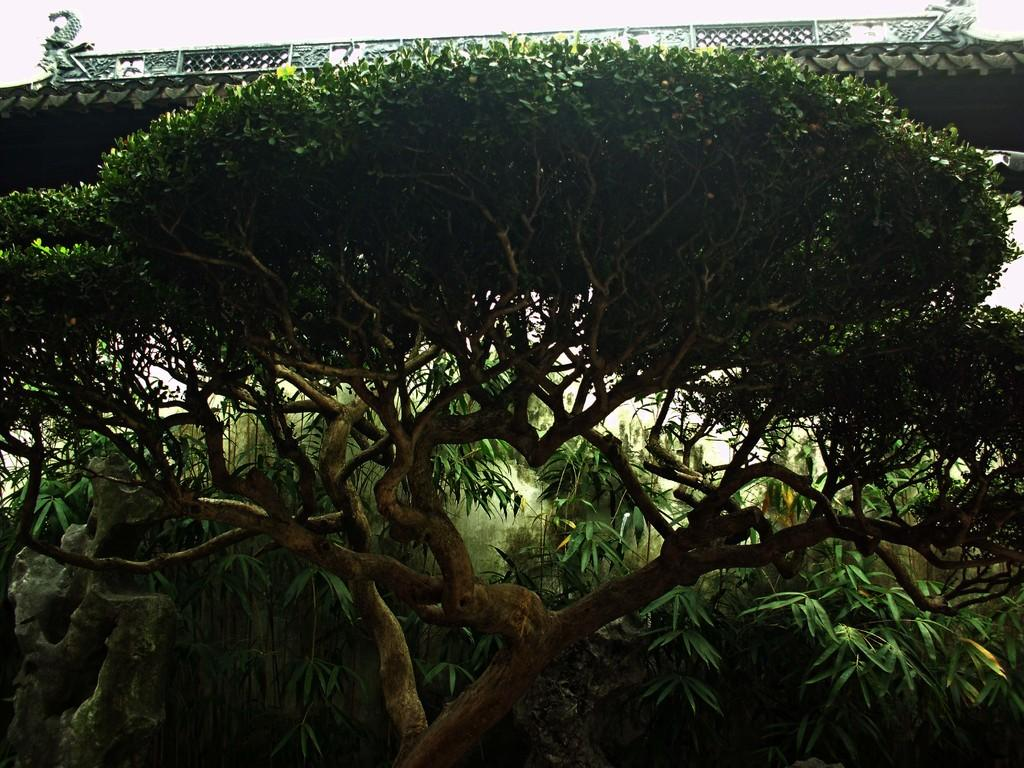What type of natural element can be seen in the image? There is a tree in the image. What else is visible in the background of the image? There are many plants behind the tree. Can you describe the structure that is on top of the tree? There is a bridge with a railing on top of the tree. How many pizzas are being served by the doctor in the image? There is no doctor or pizza present in the image. 